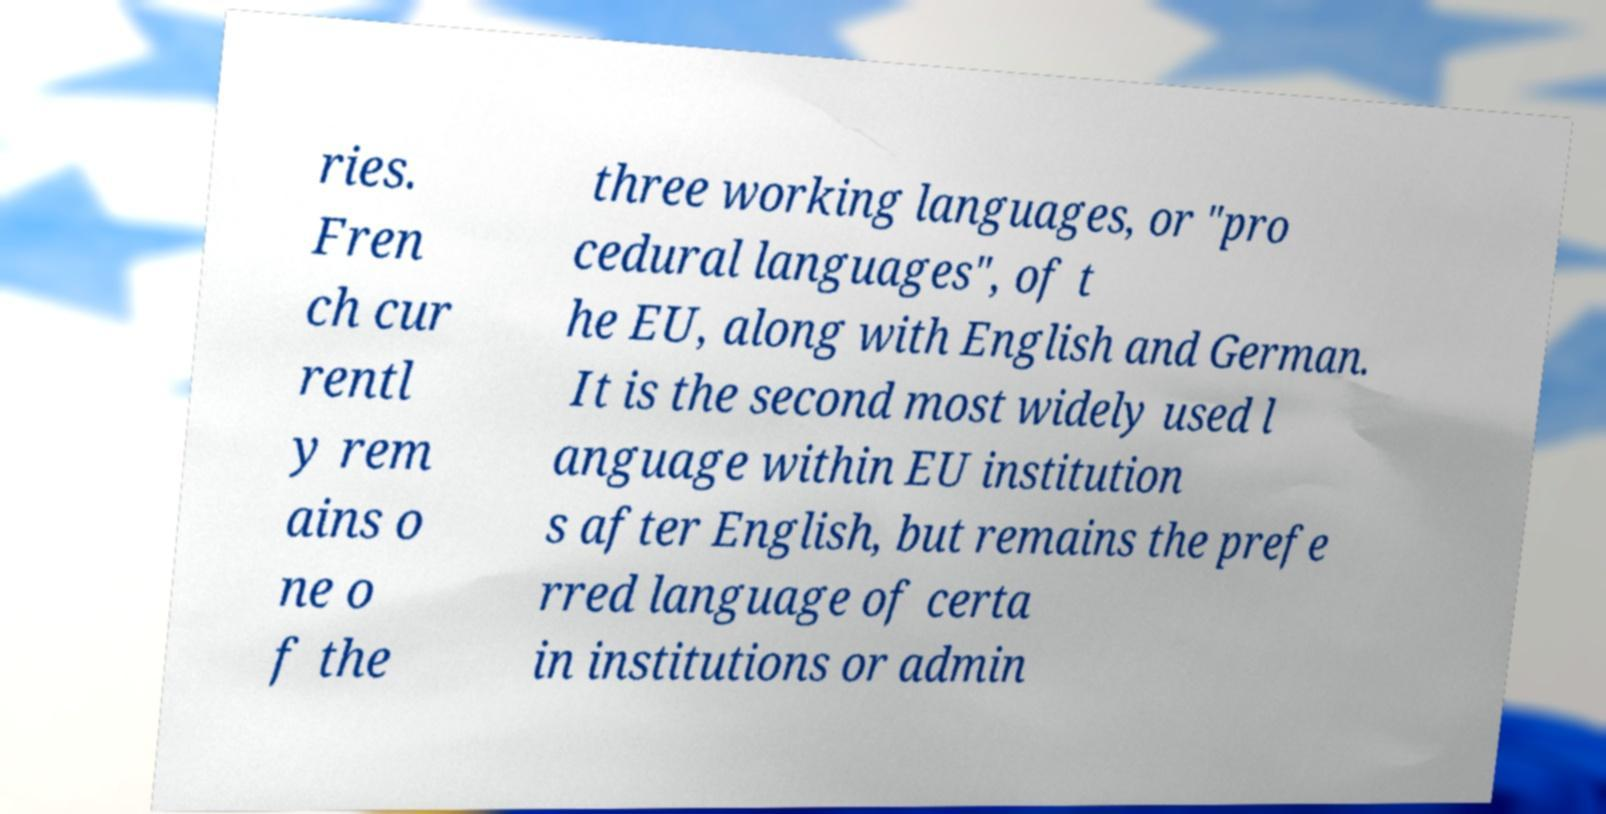What messages or text are displayed in this image? I need them in a readable, typed format. ries. Fren ch cur rentl y rem ains o ne o f the three working languages, or "pro cedural languages", of t he EU, along with English and German. It is the second most widely used l anguage within EU institution s after English, but remains the prefe rred language of certa in institutions or admin 